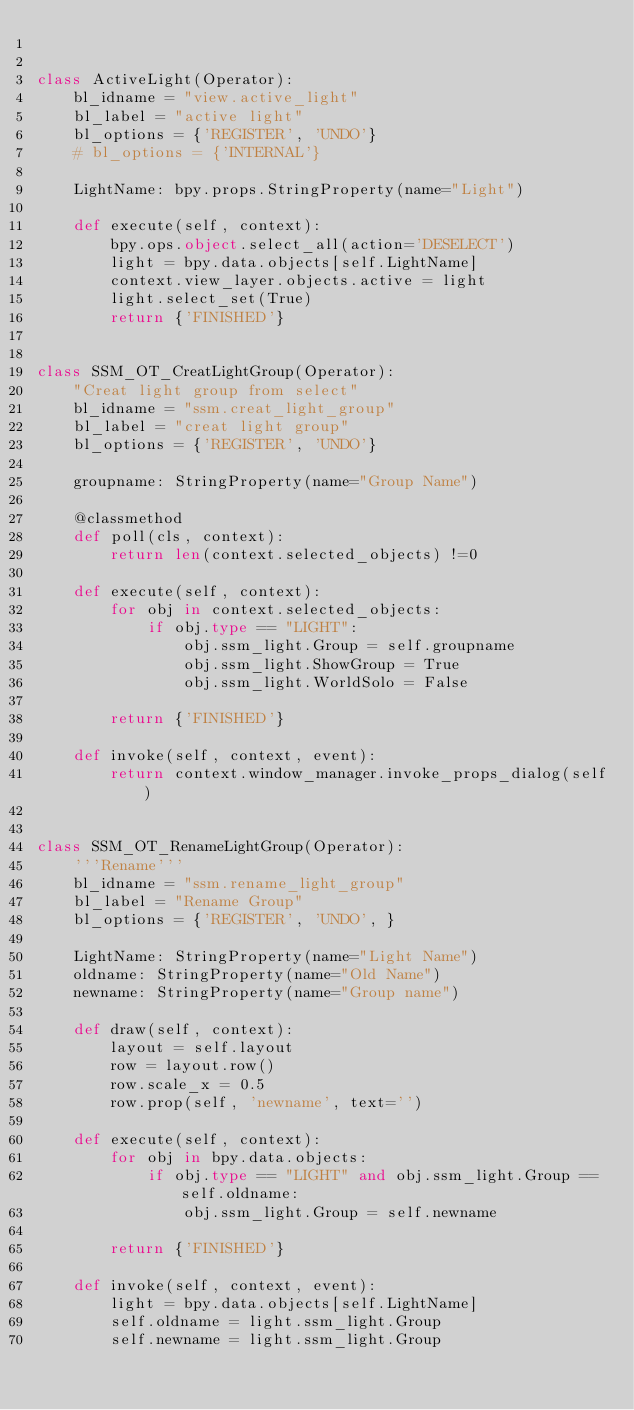<code> <loc_0><loc_0><loc_500><loc_500><_Python_>

class ActiveLight(Operator):
    bl_idname = "view.active_light"
    bl_label = "active light"
    bl_options = {'REGISTER', 'UNDO'}
    # bl_options = {'INTERNAL'}

    LightName: bpy.props.StringProperty(name="Light")

    def execute(self, context):
        bpy.ops.object.select_all(action='DESELECT')
        light = bpy.data.objects[self.LightName]
        context.view_layer.objects.active = light
        light.select_set(True)
        return {'FINISHED'}


class SSM_OT_CreatLightGroup(Operator):
    "Creat light group from select"
    bl_idname = "ssm.creat_light_group"
    bl_label = "creat light group"
    bl_options = {'REGISTER', 'UNDO'}

    groupname: StringProperty(name="Group Name")

    @classmethod
    def poll(cls, context):
        return len(context.selected_objects) !=0

    def execute(self, context):
        for obj in context.selected_objects:
            if obj.type == "LIGHT":
                obj.ssm_light.Group = self.groupname
                obj.ssm_light.ShowGroup = True
                obj.ssm_light.WorldSolo = False

        return {'FINISHED'}

    def invoke(self, context, event):
        return context.window_manager.invoke_props_dialog(self)


class SSM_OT_RenameLightGroup(Operator):
    '''Rename'''
    bl_idname = "ssm.rename_light_group"
    bl_label = "Rename Group"
    bl_options = {'REGISTER', 'UNDO', }

    LightName: StringProperty(name="Light Name")
    oldname: StringProperty(name="Old Name")
    newname: StringProperty(name="Group name")

    def draw(self, context):
        layout = self.layout
        row = layout.row()
        row.scale_x = 0.5
        row.prop(self, 'newname', text='')

    def execute(self, context):
        for obj in bpy.data.objects:
            if obj.type == "LIGHT" and obj.ssm_light.Group == self.oldname:
                obj.ssm_light.Group = self.newname

        return {'FINISHED'}

    def invoke(self, context, event):
        light = bpy.data.objects[self.LightName]
        self.oldname = light.ssm_light.Group
        self.newname = light.ssm_light.Group
</code> 